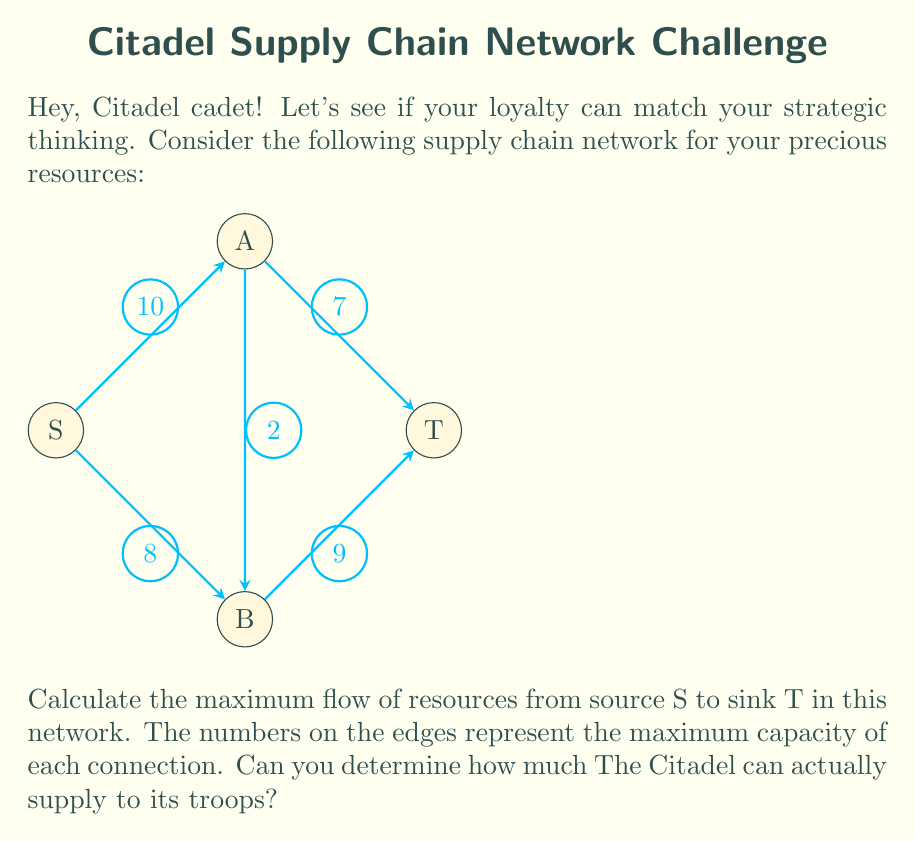Give your solution to this math problem. To solve this problem, we'll use the Ford-Fulkerson algorithm to find the maximum flow in the network. Here's the step-by-step process:

1) Initialize the flow to 0 for all edges.

2) Find an augmenting path from S to T:
   Path 1: S → A → T (min capacity = 7)
   Increase flow by 7
   Residual graph:
   S → A: 3, A → T: 0, S → B: 8, B → T: 9, A → B: 2

3) Find another augmenting path:
   Path 2: S → B → T (min capacity = 8)
   Increase flow by 8
   Residual graph:
   S → A: 3, A → T: 0, S → B: 0, B → T: 1, A → B: 2

4) Find another augmenting path:
   Path 3: S → A → B → T (min capacity = 1)
   Increase flow by 1
   Residual graph:
   S → A: 2, A → T: 0, S → B: 0, B → T: 0, A → B: 1

5) No more augmenting paths exist, so the algorithm terminates.

The maximum flow is the sum of all flow increases:
$$\text{Max Flow} = 7 + 8 + 1 = 16$$

This means The Citadel can supply a maximum of 16 units of resources to its troops through this network.
Answer: 16 units 